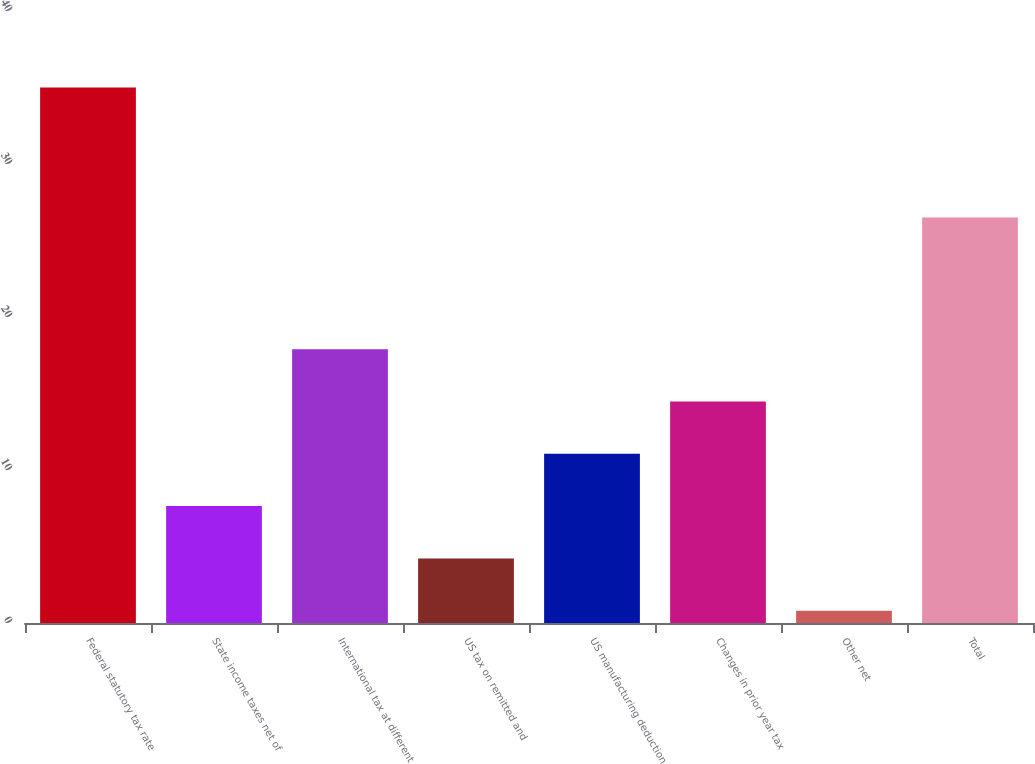Convert chart. <chart><loc_0><loc_0><loc_500><loc_500><bar_chart><fcel>Federal statutory tax rate<fcel>State income taxes net of<fcel>International tax at different<fcel>US tax on remitted and<fcel>US manufacturing deduction<fcel>Changes in prior year tax<fcel>Other net<fcel>Total<nl><fcel>35<fcel>7.64<fcel>17.9<fcel>4.22<fcel>11.06<fcel>14.48<fcel>0.8<fcel>26.5<nl></chart> 